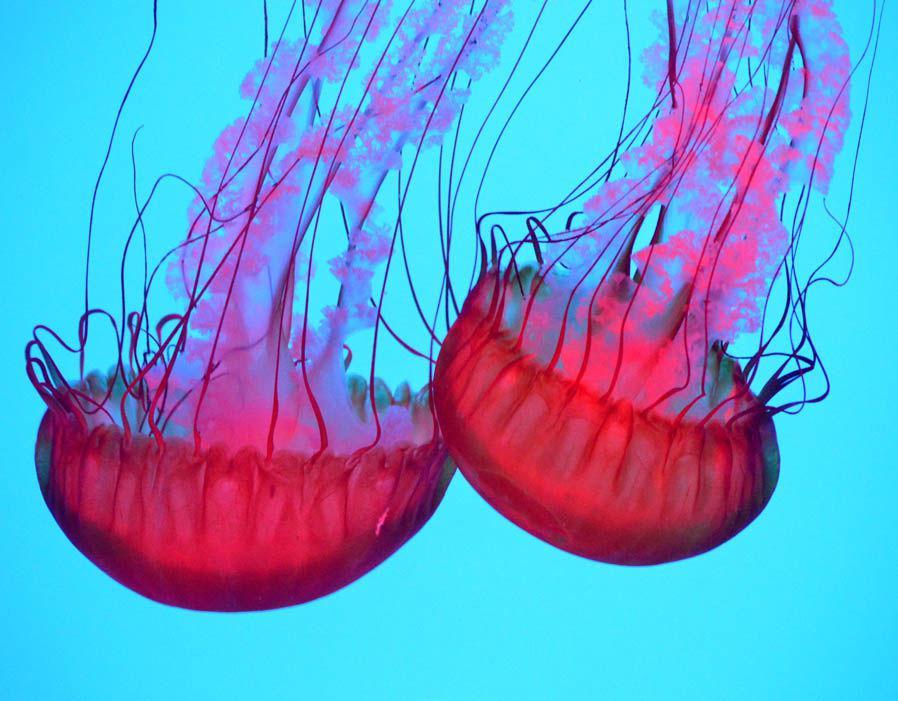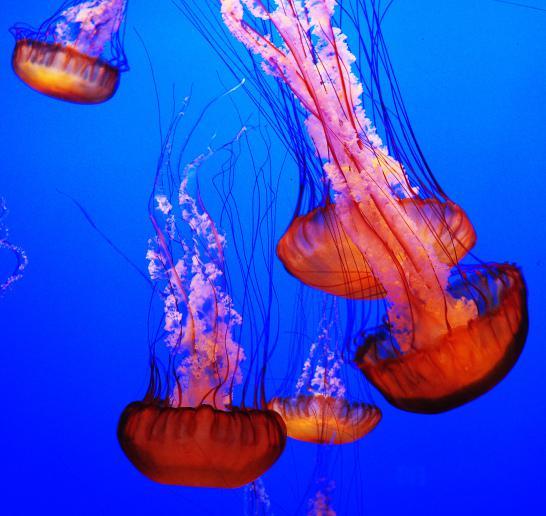The first image is the image on the left, the second image is the image on the right. Assess this claim about the two images: "all of the jellyfish are swimming with the body facing downward". Correct or not? Answer yes or no. Yes. The first image is the image on the left, the second image is the image on the right. Considering the images on both sides, is "There are at least 7 jellyfish swimming down." valid? Answer yes or no. Yes. 